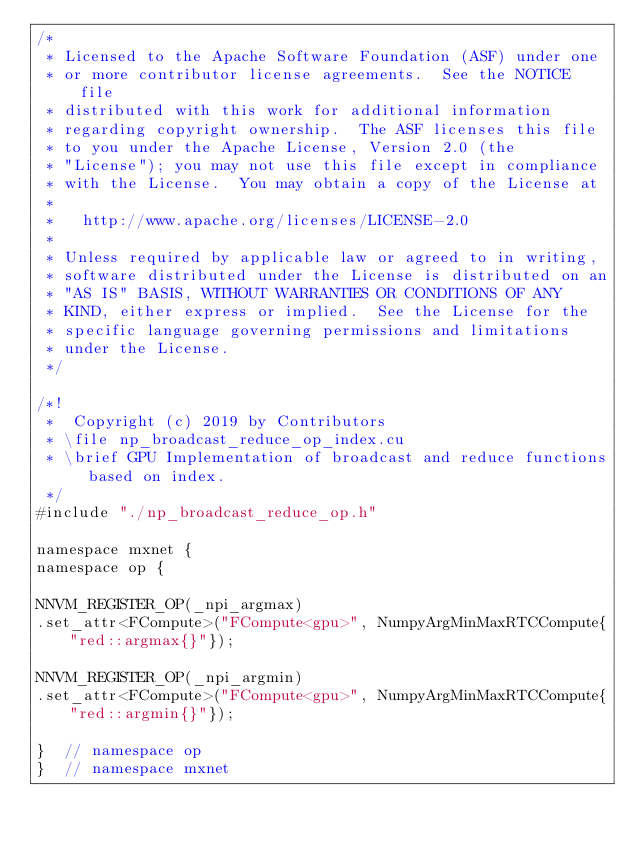<code> <loc_0><loc_0><loc_500><loc_500><_Cuda_>/*
 * Licensed to the Apache Software Foundation (ASF) under one
 * or more contributor license agreements.  See the NOTICE file
 * distributed with this work for additional information
 * regarding copyright ownership.  The ASF licenses this file
 * to you under the Apache License, Version 2.0 (the
 * "License"); you may not use this file except in compliance
 * with the License.  You may obtain a copy of the License at
 *
 *   http://www.apache.org/licenses/LICENSE-2.0
 *
 * Unless required by applicable law or agreed to in writing,
 * software distributed under the License is distributed on an
 * "AS IS" BASIS, WITHOUT WARRANTIES OR CONDITIONS OF ANY
 * KIND, either express or implied.  See the License for the
 * specific language governing permissions and limitations
 * under the License.
 */

/*!
 *  Copyright (c) 2019 by Contributors
 * \file np_broadcast_reduce_op_index.cu
 * \brief GPU Implementation of broadcast and reduce functions based on index.
 */
#include "./np_broadcast_reduce_op.h"

namespace mxnet {
namespace op {

NNVM_REGISTER_OP(_npi_argmax)
.set_attr<FCompute>("FCompute<gpu>", NumpyArgMinMaxRTCCompute{"red::argmax{}"});

NNVM_REGISTER_OP(_npi_argmin)
.set_attr<FCompute>("FCompute<gpu>", NumpyArgMinMaxRTCCompute{"red::argmin{}"});

}  // namespace op
}  // namespace mxnet
</code> 